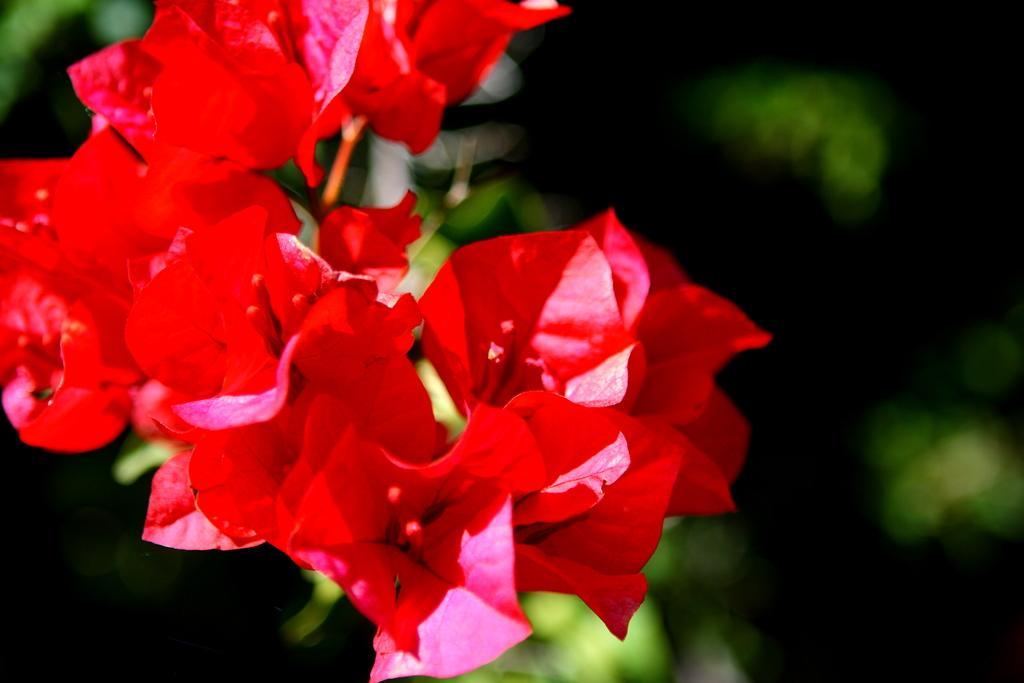In one or two sentences, can you explain what this image depicts? In this image we can see flowers and in the background the image is blur. 